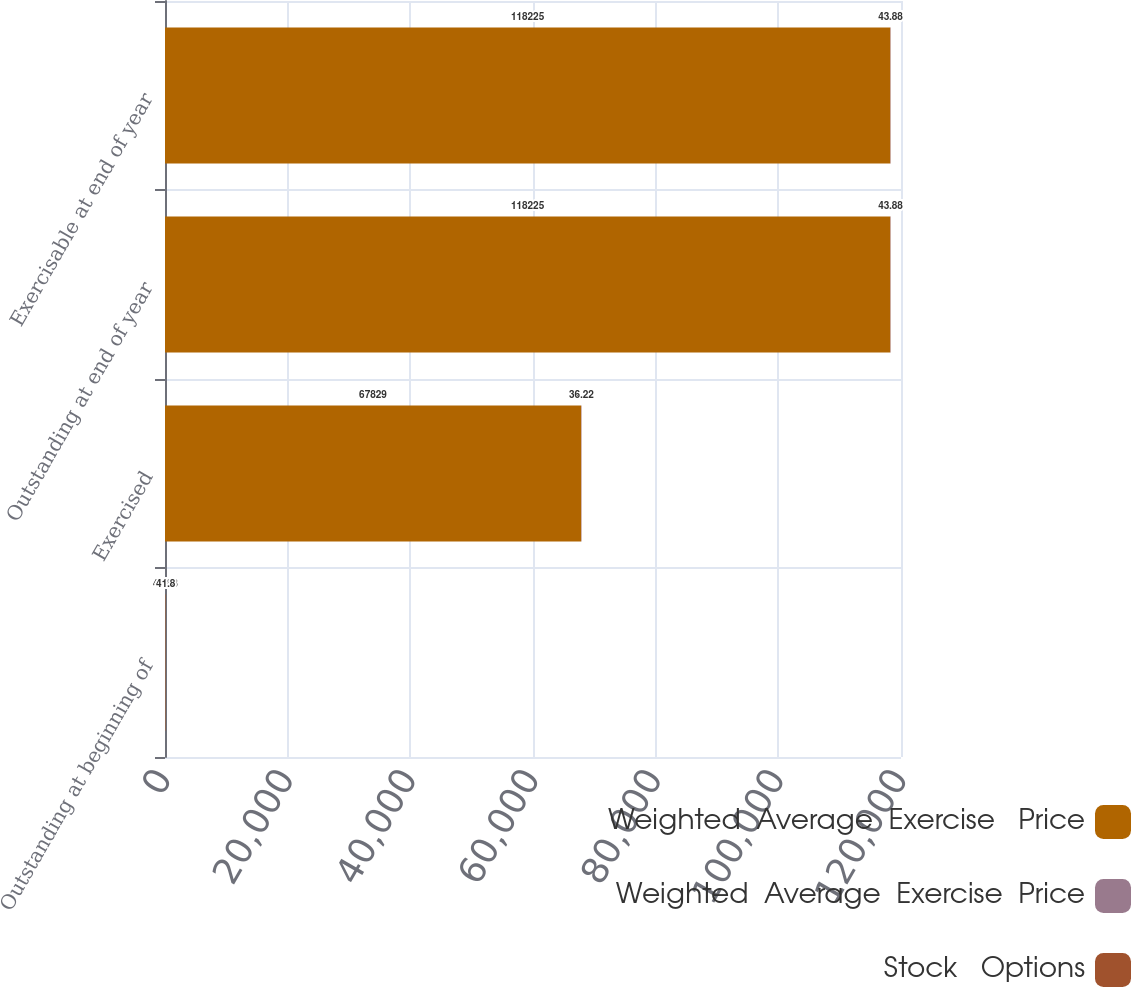Convert chart to OTSL. <chart><loc_0><loc_0><loc_500><loc_500><stacked_bar_chart><ecel><fcel>Outstanding at beginning of<fcel>Exercised<fcel>Outstanding at end of year<fcel>Exercisable at end of year<nl><fcel>Weighted  Average  Exercise   Price<fcel>43.88<fcel>67829<fcel>118225<fcel>118225<nl><fcel>Weighted  Average  Exercise  Price<fcel>43.88<fcel>44.46<fcel>43.55<fcel>43.55<nl><fcel>Stock   Options<fcel>41.8<fcel>36.22<fcel>43.88<fcel>43.88<nl></chart> 